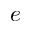<formula> <loc_0><loc_0><loc_500><loc_500>e</formula> 